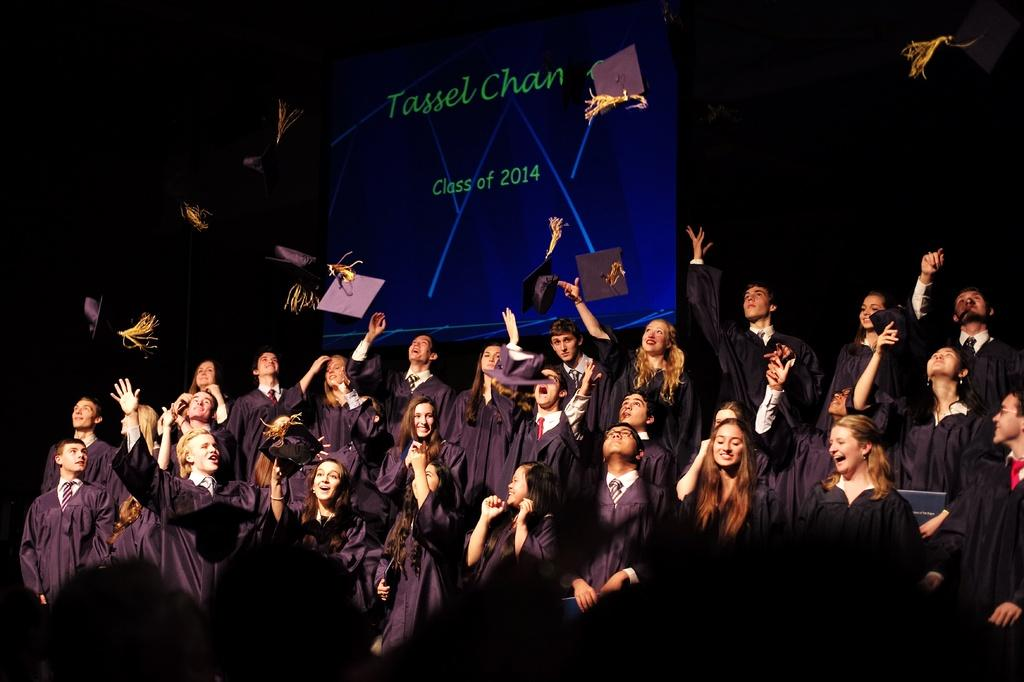Who or what is present in the image? There are people in the image. What are the people wearing? The people are wearing coats. What action are some of the people performing? Some people are throwing hats. What can be seen in the background of the image? There is a screen in the background of the image. What type of adjustment is being made to the branch in the image? There is no branch present in the image. How many wrens can be seen in the image? There are no wrens present in the image. 